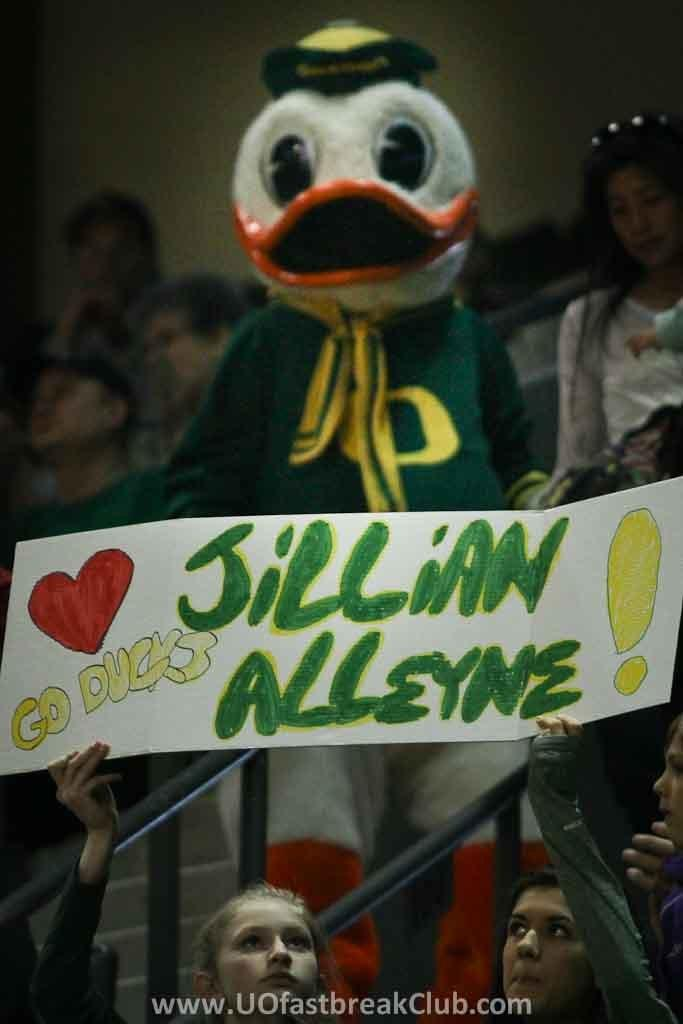What object can be seen in the image that is typically used for play? There is a toy in the image. What is the girls holding in the image? Two girls are holding a banner in the image. What can be observed in the background of the image? There are many people in the background of the image. What architectural feature is present in the image? There are railings in the image. Is there any text or logo visible in the image? There is a watermark at the bottom of the image. What type of comb is being used by the girls in the image? There is no comb visible in the image; the girls are holding a banner. How many ducks are swimming in the watermark at the bottom of the image? There are no ducks present in the image, as the watermark does not depict any animals. 